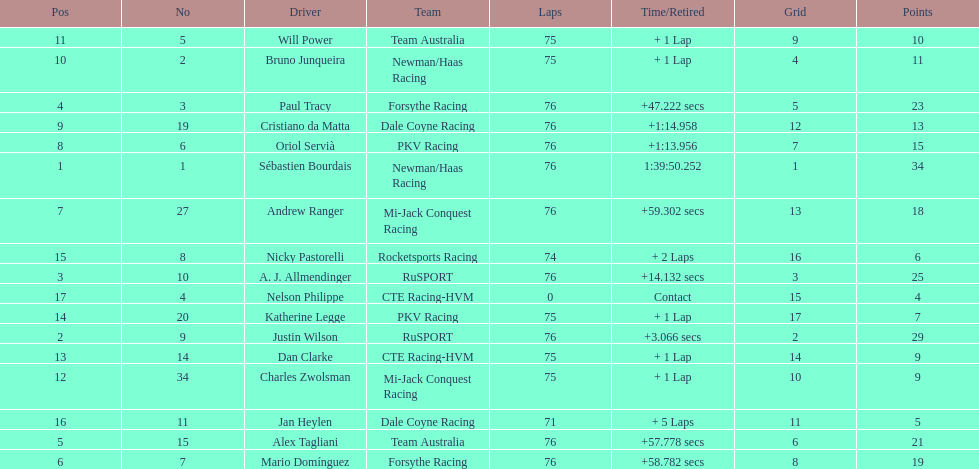Which driver has the least amount of points? Nelson Philippe. 